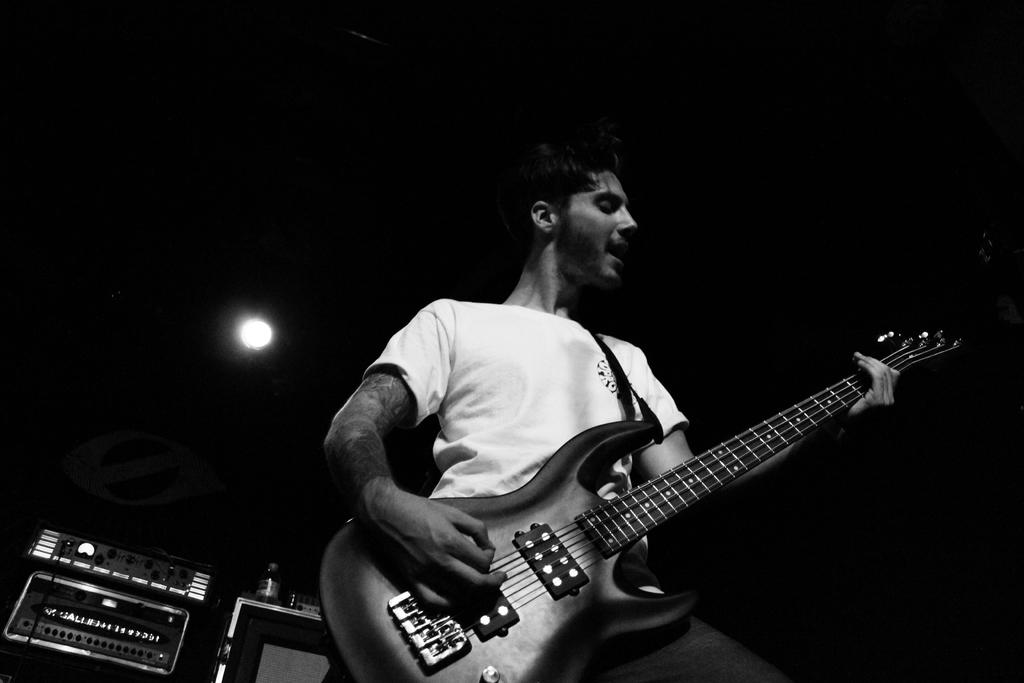What is the main subject of the image? There is a person in the image. What is the person doing in the image? The person is playing a guitar. What type of wool is the person using to play the guitar in the image? There is no wool present in the image, and the person is playing a guitar, not using wool. 